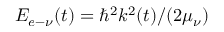Convert formula to latex. <formula><loc_0><loc_0><loc_500><loc_500>E _ { e - \nu } ( t ) = \hbar { ^ } { 2 } k ^ { 2 } ( t ) / ( 2 \mu _ { \nu } )</formula> 